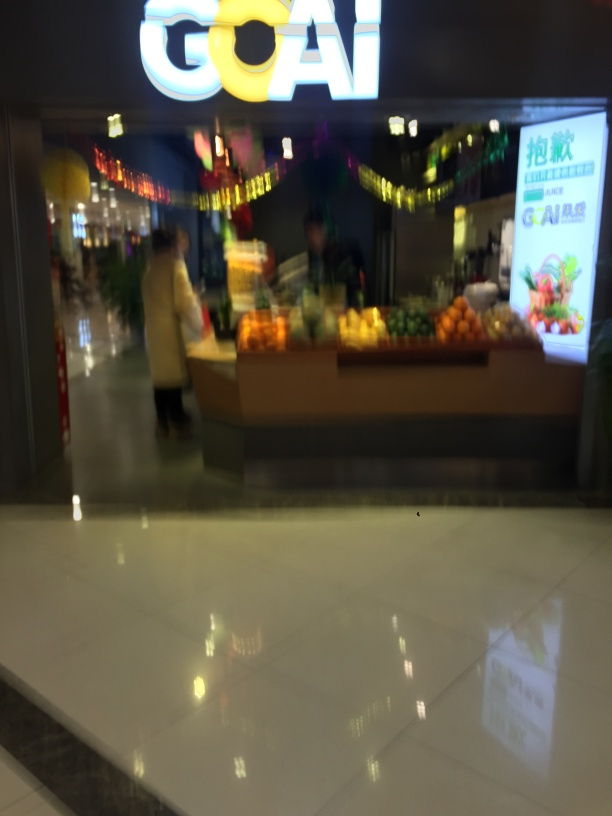Can you tell me if the location is busy? From the image, it seems fairly quiet with only a few visible persons. However, due to the blurriness of the image, it's difficult to accurately determine the foot traffic or bustle within the location. Is there any sign or information in the image that can tell us more about the place? The illuminated sign 'GOAI' could be the name of the establishment or a brand associated with it, but the blurriness hampers our ability to gather more detailed information. 